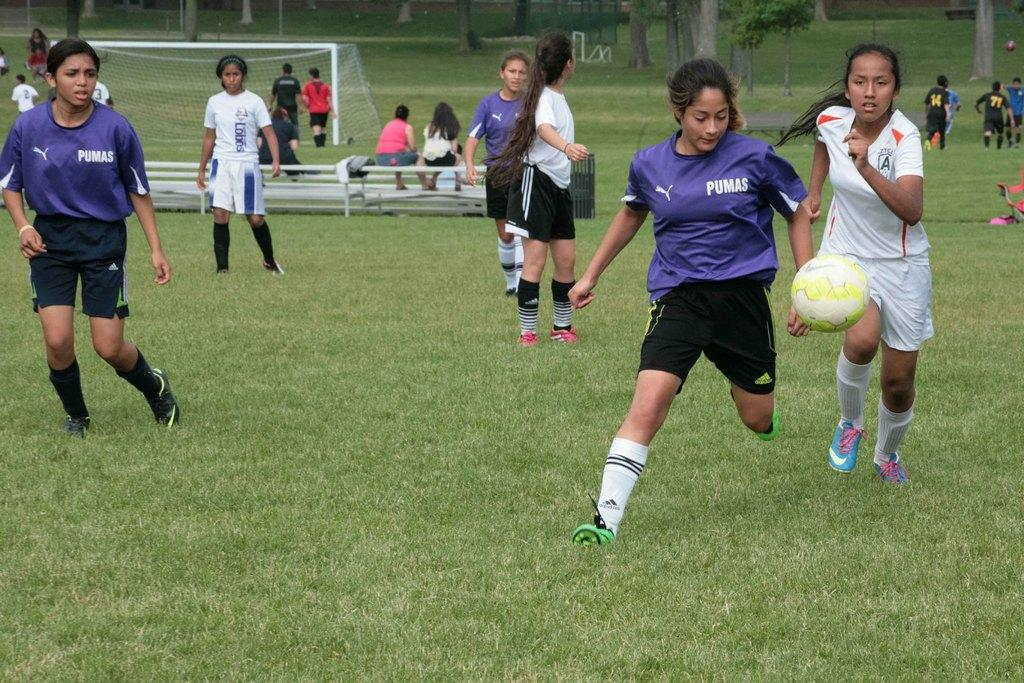<image>
Offer a succinct explanation of the picture presented. Two teams of young women are playing soccer with Pumas jerseys. 